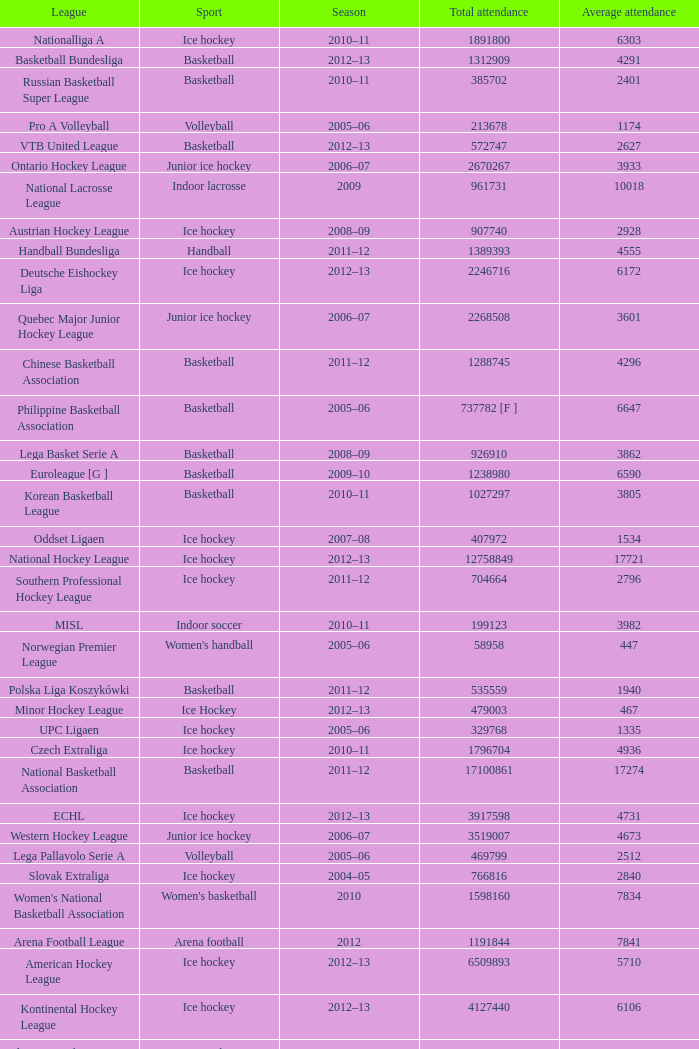What's the average attendance of the league with a total attendance of 2268508? 3601.0. 